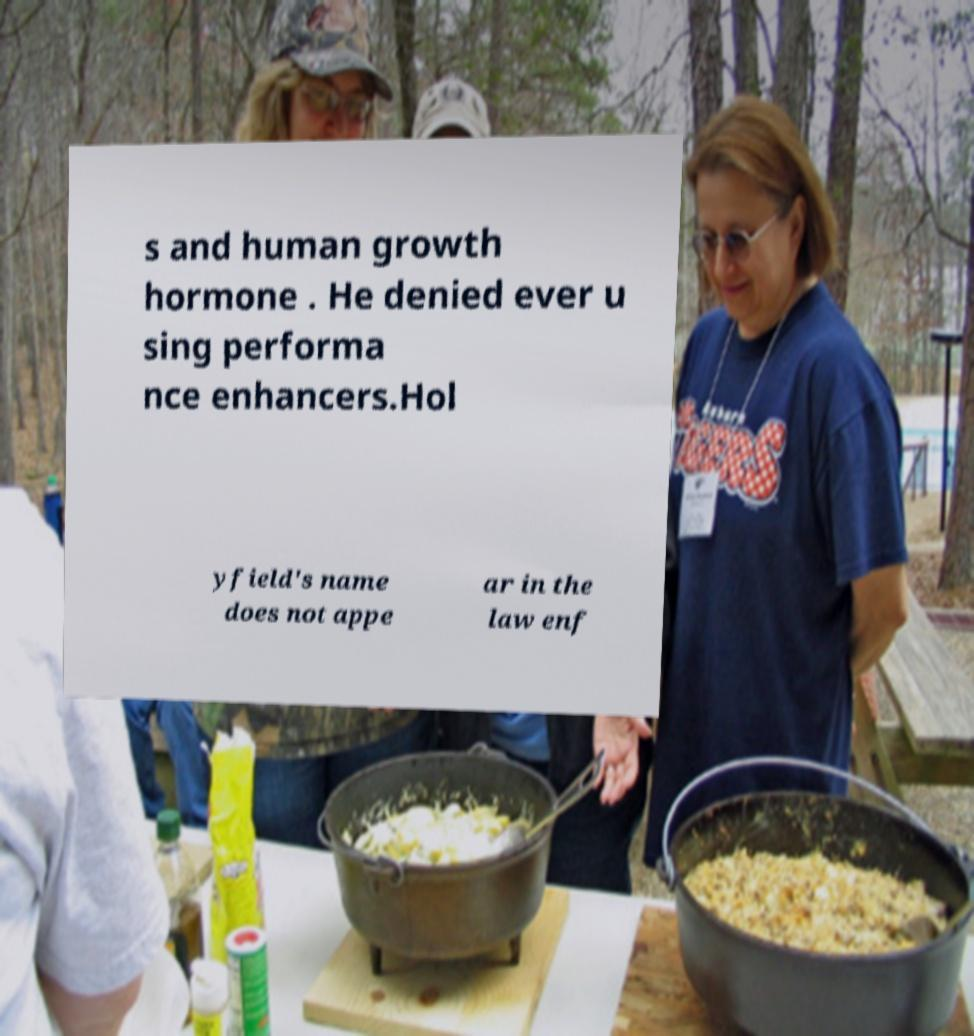I need the written content from this picture converted into text. Can you do that? s and human growth hormone . He denied ever u sing performa nce enhancers.Hol yfield's name does not appe ar in the law enf 